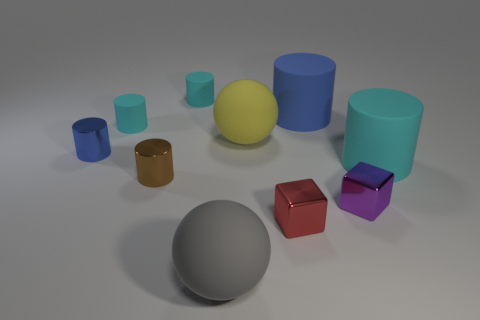How does the lighting affect the colors of the objects in the image? The image features diffused lighting that softens shadows and minimizes contrast, which allows the intrinsic colors of the objects to appear more true to life without being overly bright or subdued. 